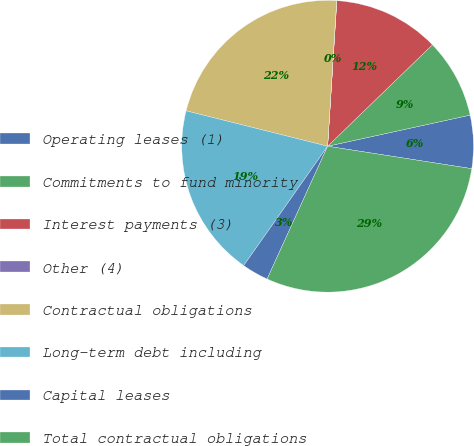Convert chart. <chart><loc_0><loc_0><loc_500><loc_500><pie_chart><fcel>Operating leases (1)<fcel>Commitments to fund minority<fcel>Interest payments (3)<fcel>Other (4)<fcel>Contractual obligations<fcel>Long-term debt including<fcel>Capital leases<fcel>Total contractual obligations<nl><fcel>5.88%<fcel>8.82%<fcel>11.75%<fcel>0.02%<fcel>22.09%<fcel>19.15%<fcel>2.95%<fcel>29.35%<nl></chart> 